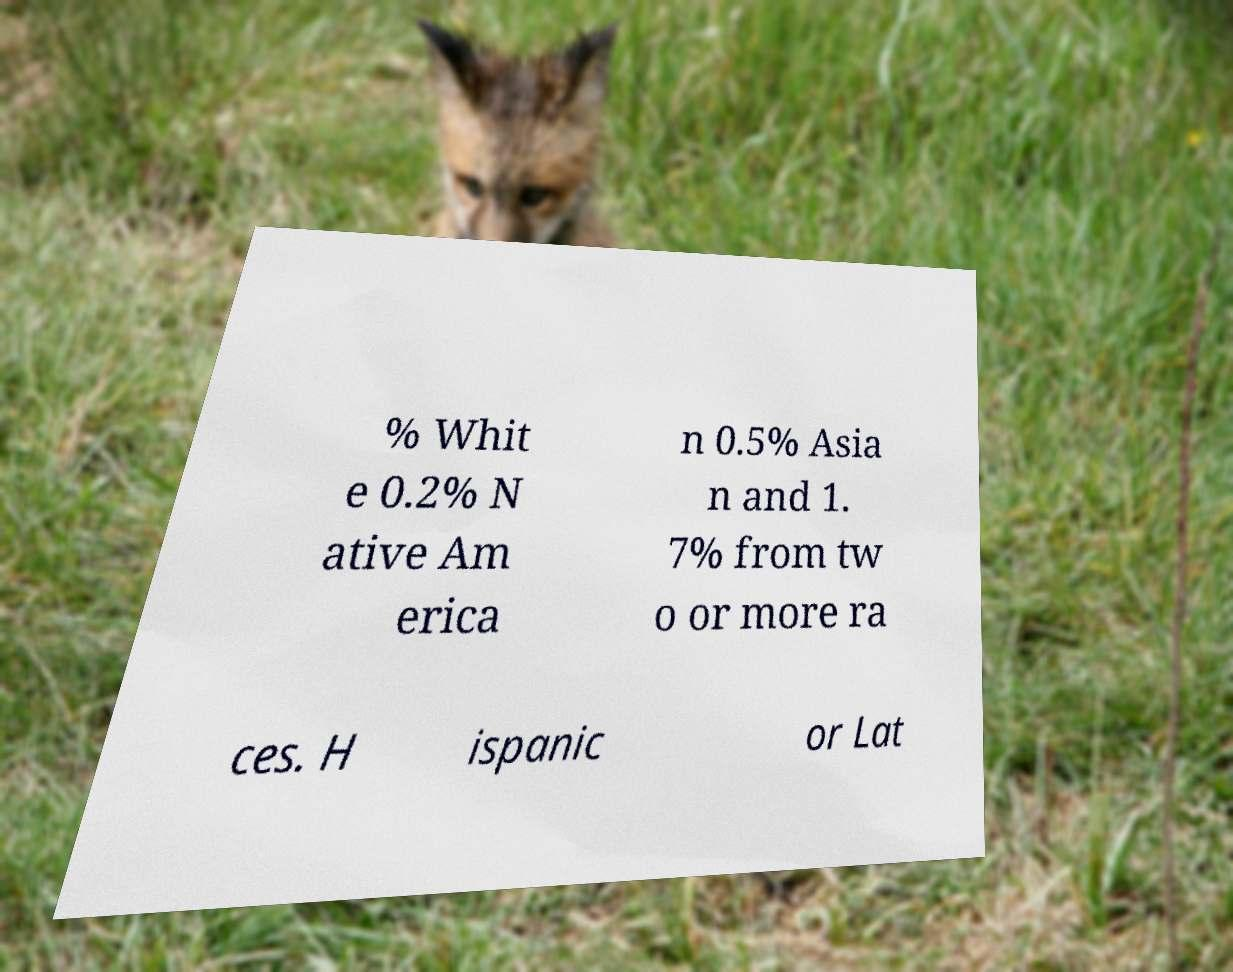I need the written content from this picture converted into text. Can you do that? % Whit e 0.2% N ative Am erica n 0.5% Asia n and 1. 7% from tw o or more ra ces. H ispanic or Lat 